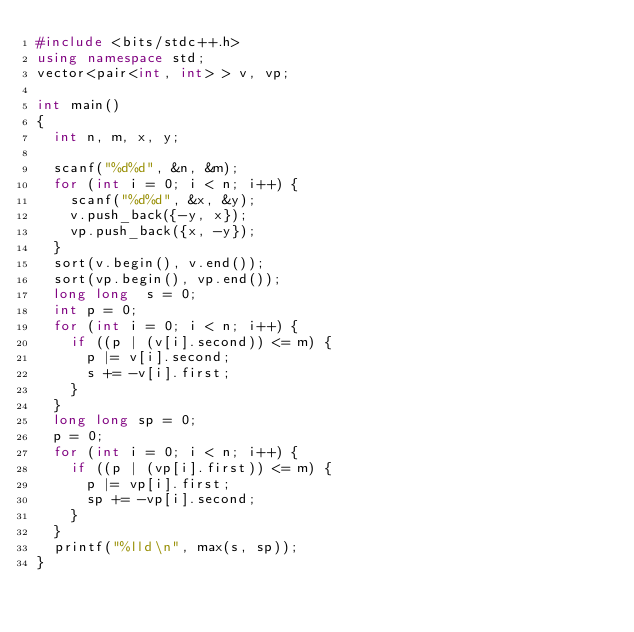Convert code to text. <code><loc_0><loc_0><loc_500><loc_500><_C++_>#include <bits/stdc++.h>
using namespace std;
vector<pair<int, int> > v, vp;

int main()
{
	int n, m, x, y;
	
	scanf("%d%d", &n, &m);
	for (int i = 0; i < n; i++) {
		scanf("%d%d", &x, &y);
		v.push_back({-y, x});
		vp.push_back({x, -y});
	}
	sort(v.begin(), v.end());
	sort(vp.begin(), vp.end());
	long long  s = 0;
	int p = 0;
	for (int i = 0; i < n; i++) {
		if ((p | (v[i].second)) <= m) {
			p |= v[i].second;
			s += -v[i].first;
		}
	}
	long long sp = 0;
	p = 0;
	for (int i = 0; i < n; i++) {
		if ((p | (vp[i].first)) <= m) {
			p |= vp[i].first;
			sp += -vp[i].second;
		}
	}
	printf("%lld\n", max(s, sp));
}
</code> 